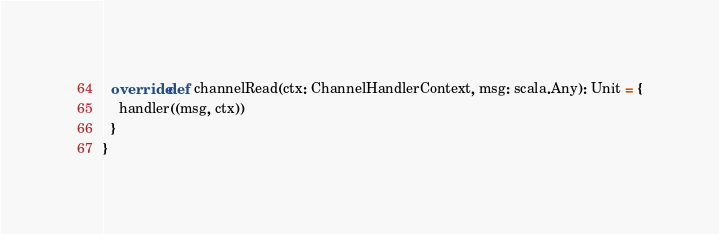<code> <loc_0><loc_0><loc_500><loc_500><_Scala_>  override def channelRead(ctx: ChannelHandlerContext, msg: scala.Any): Unit = {
    handler((msg, ctx))
  }
}
</code> 